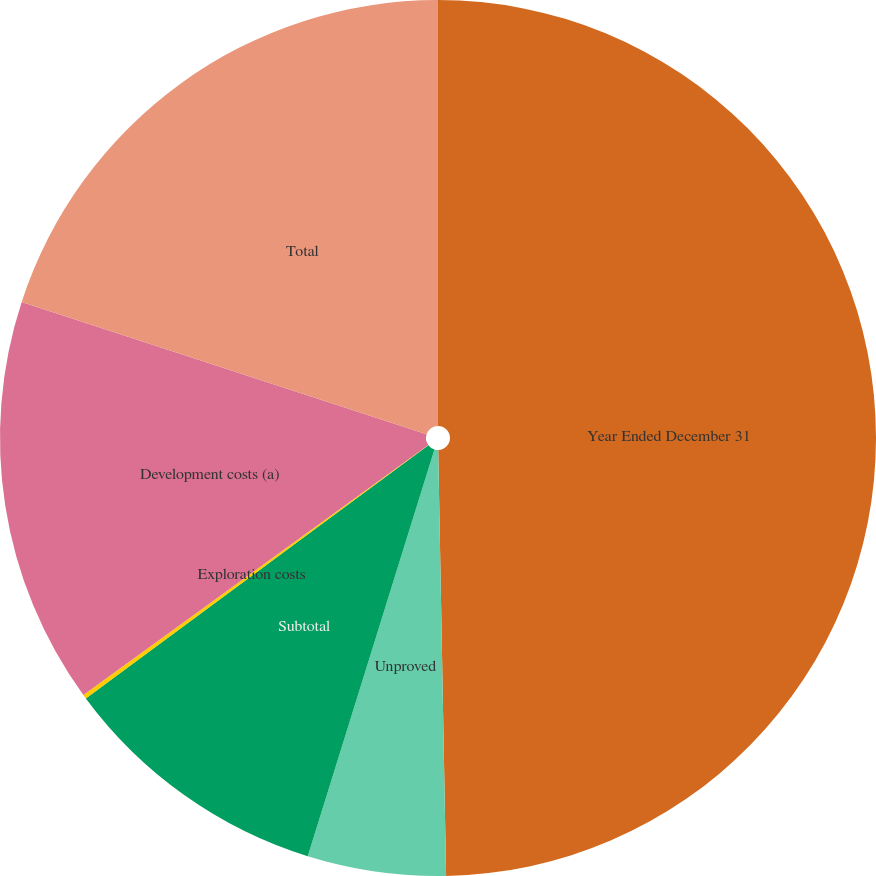Convert chart. <chart><loc_0><loc_0><loc_500><loc_500><pie_chart><fcel>Year Ended December 31<fcel>Unproved<fcel>Subtotal<fcel>Exploration costs<fcel>Development costs (a)<fcel>Total<nl><fcel>49.7%<fcel>5.1%<fcel>10.06%<fcel>0.15%<fcel>15.01%<fcel>19.97%<nl></chart> 